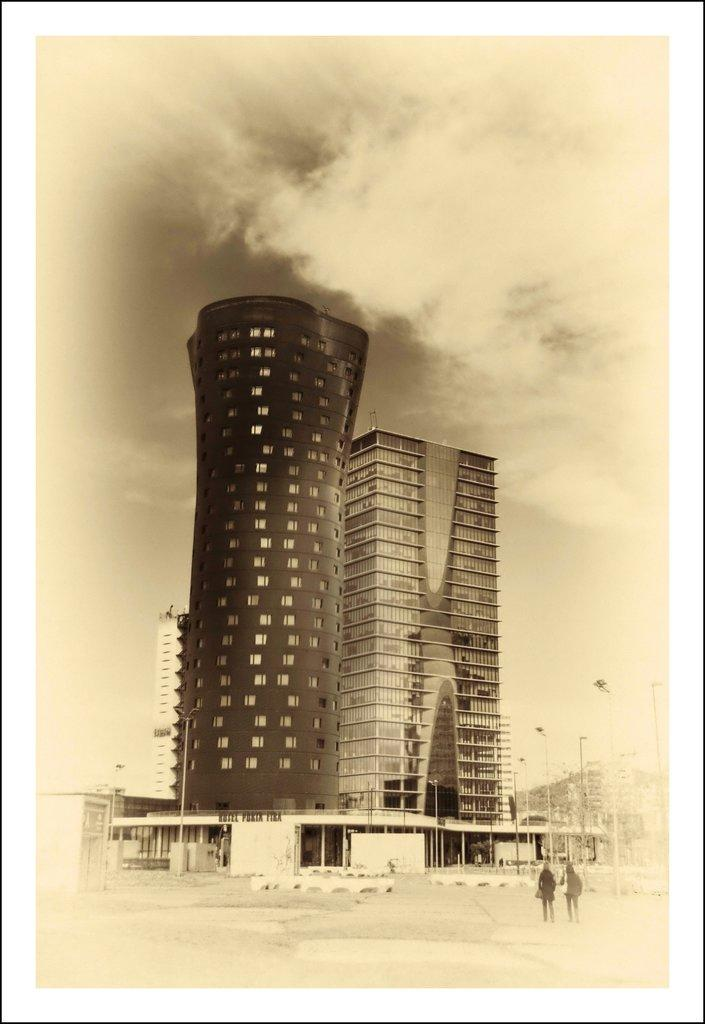What type of structures can be seen in the image? There are buildings in the image. What else can be seen in the image besides the buildings? There are poles in the image. Are there any people visible in the image? Yes, two persons are standing on the road. What is visible in the background of the image? The sky is visible in the image. What type of produce can be seen growing on the earth in the image? There is no produce or earth visible in the image; it primarily features buildings, poles, and people. How fast are the persons running on the road in the image? There is no indication that the persons are running in the image; they are simply standing on the road. 